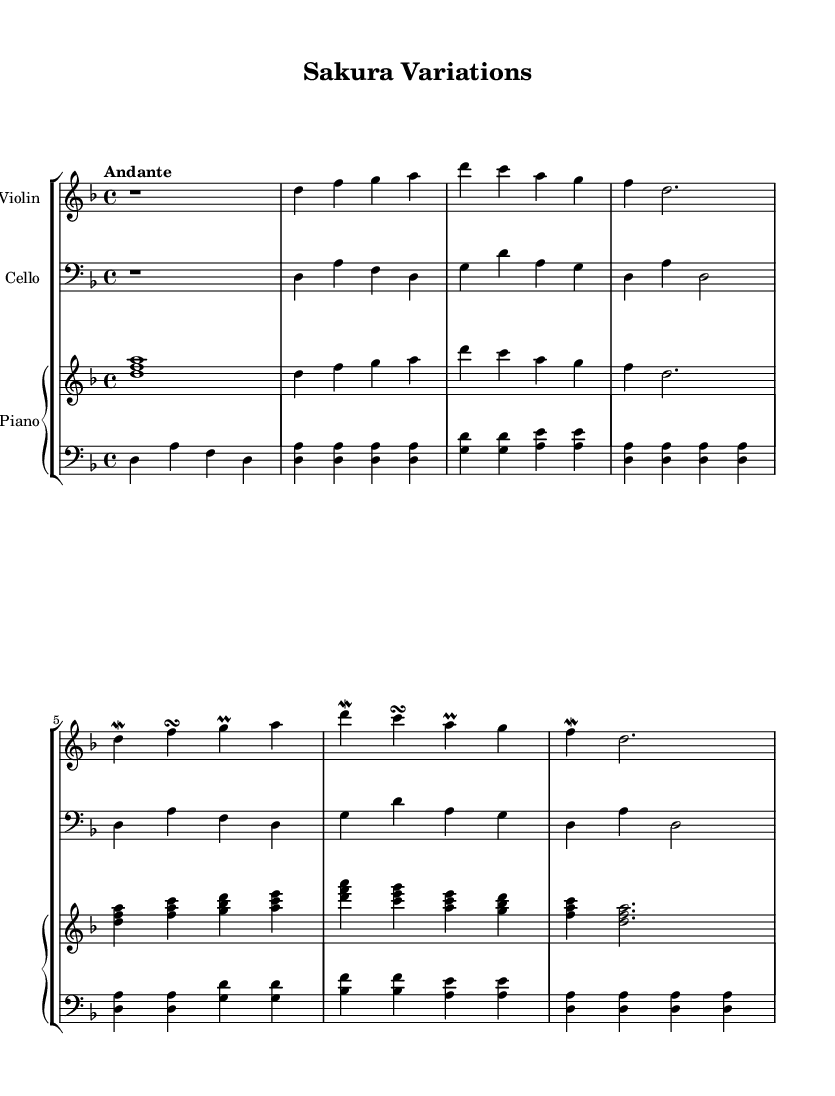What is the key signature of this music? The key signature is indicated at the beginning of the staff lines, which shows two flats (B♭ and E♭).
Answer: D minor What is the time signature for this piece? The time signature appears at the beginning of the music as a fraction, indicating how many beats are in each measure. Here, it shows a 4 over 4.
Answer: 4/4 What is the tempo marking for this composition? The tempo is marked above the staff, indicating the speed at which the piece should be played. It states "Andante," which generally indicates a moderate pace.
Answer: Andante How many variations are present in this piece? The piece is labeled as having a "Theme" and at least one "Variation" in its structure. The notation comments indicate that there is Variation 1; therefore, we can conclude there is at least one variation.
Answer: 1 What instruments are scored in this sheet music? The names of the instruments are noted at the beginning of each staff, which includes Violin, Cello, and Piano, indicating that these three instruments are part of the score.
Answer: Violin, Cello, Piano Which is the highest pitch in the violin part? By examining the notes written in the violin part, the highest note produced is 'a' in the third measure.
Answer: a 